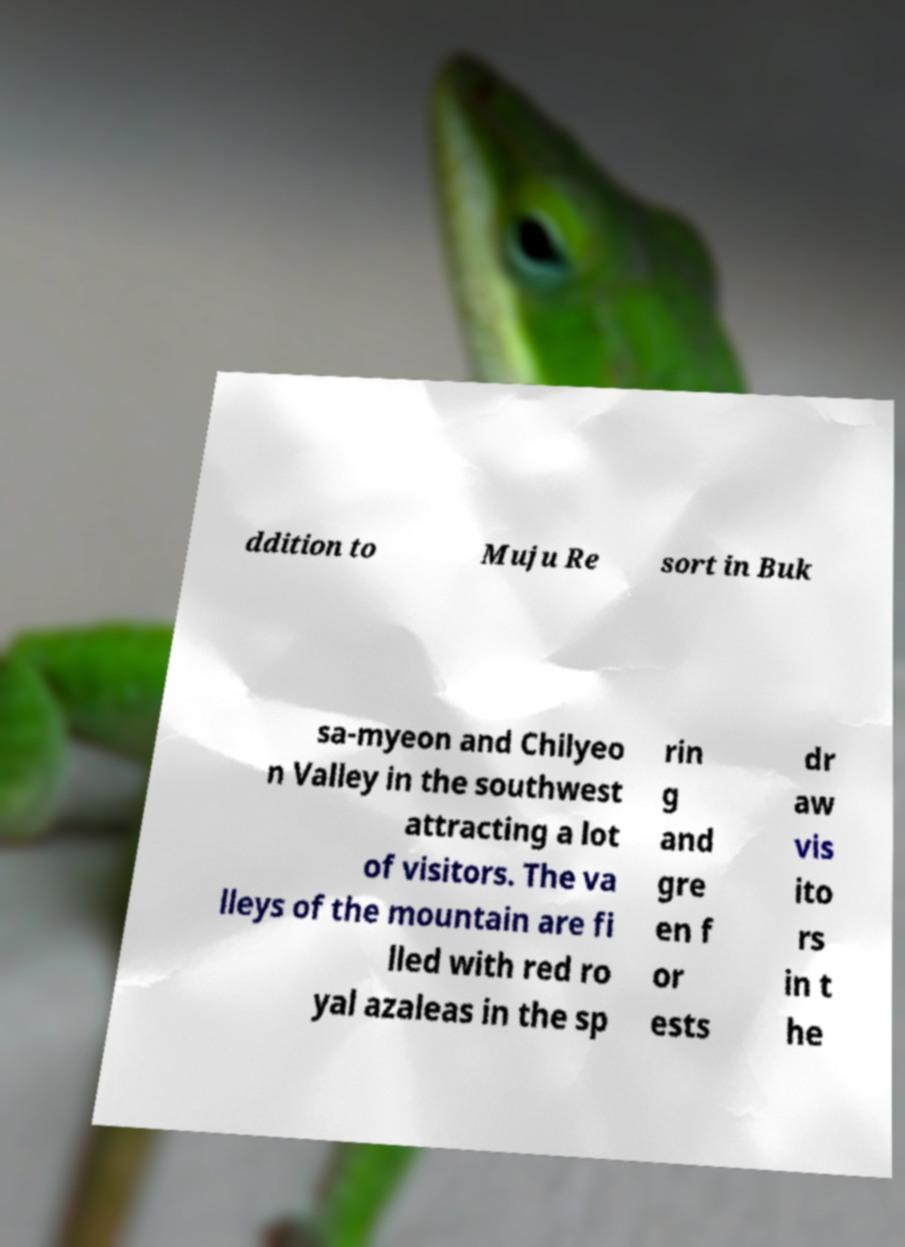For documentation purposes, I need the text within this image transcribed. Could you provide that? ddition to Muju Re sort in Buk sa-myeon and Chilyeo n Valley in the southwest attracting a lot of visitors. The va lleys of the mountain are fi lled with red ro yal azaleas in the sp rin g and gre en f or ests dr aw vis ito rs in t he 